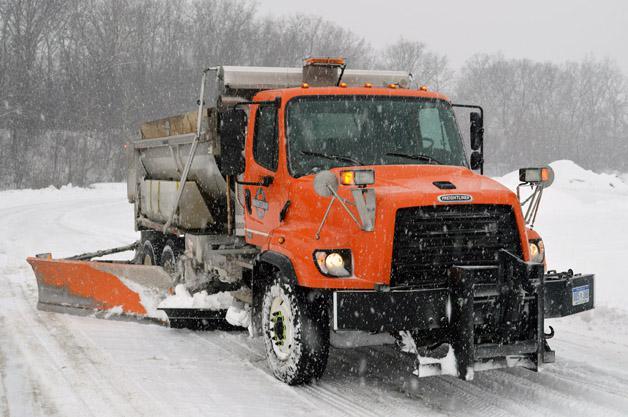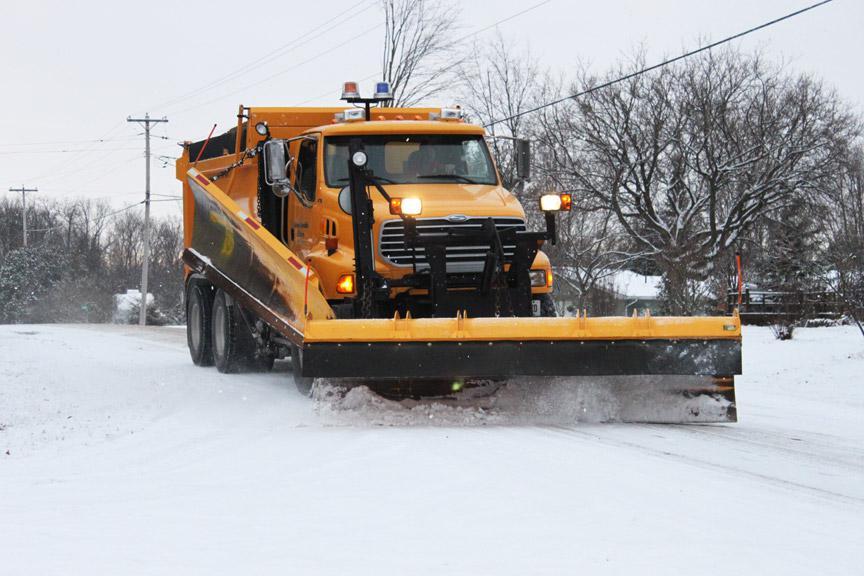The first image is the image on the left, the second image is the image on the right. Analyze the images presented: Is the assertion "The truck is passing a building in one of the iamges." valid? Answer yes or no. No. 